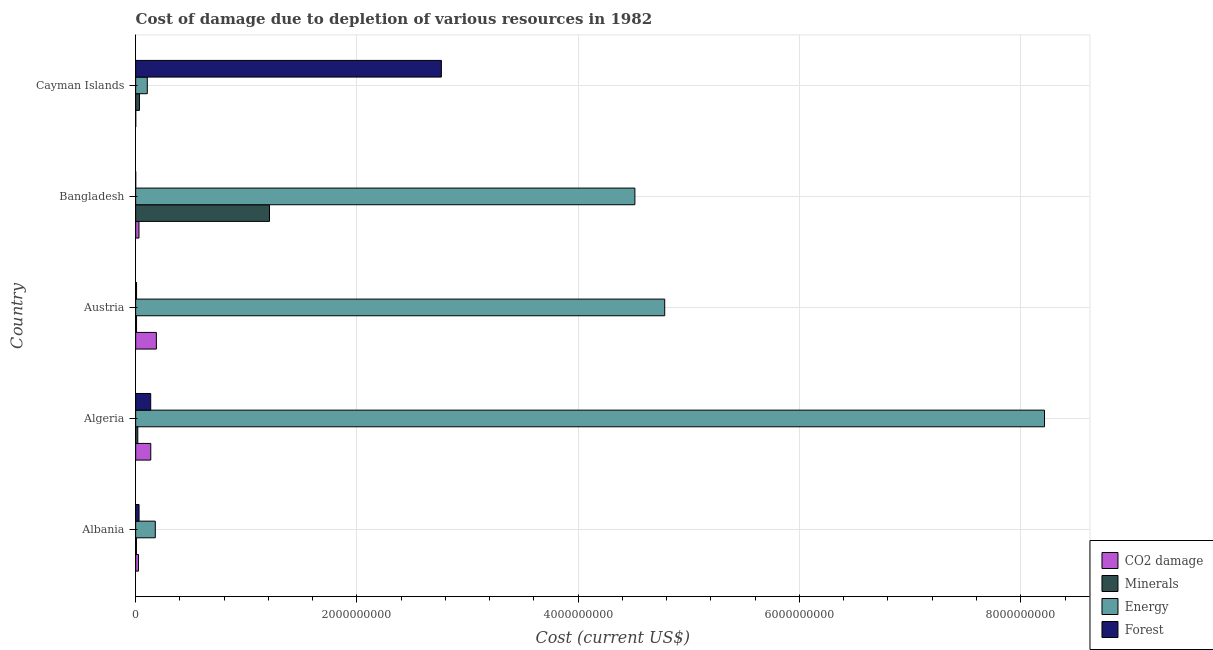How many different coloured bars are there?
Your answer should be very brief. 4. Are the number of bars per tick equal to the number of legend labels?
Your response must be concise. Yes. How many bars are there on the 2nd tick from the top?
Make the answer very short. 4. What is the cost of damage due to depletion of energy in Albania?
Make the answer very short. 1.77e+08. Across all countries, what is the maximum cost of damage due to depletion of forests?
Give a very brief answer. 2.76e+09. Across all countries, what is the minimum cost of damage due to depletion of energy?
Offer a very short reply. 1.05e+08. In which country was the cost of damage due to depletion of energy minimum?
Provide a short and direct response. Cayman Islands. What is the total cost of damage due to depletion of coal in the graph?
Make the answer very short. 3.79e+08. What is the difference between the cost of damage due to depletion of energy in Albania and that in Cayman Islands?
Provide a succinct answer. 7.23e+07. What is the difference between the cost of damage due to depletion of minerals in Bangladesh and the cost of damage due to depletion of energy in Austria?
Offer a terse response. -3.57e+09. What is the average cost of damage due to depletion of energy per country?
Keep it short and to the point. 3.56e+09. What is the difference between the cost of damage due to depletion of energy and cost of damage due to depletion of minerals in Algeria?
Provide a short and direct response. 8.20e+09. In how many countries, is the cost of damage due to depletion of minerals greater than 800000000 US$?
Your answer should be very brief. 1. What is the ratio of the cost of damage due to depletion of coal in Albania to that in Austria?
Your answer should be compact. 0.14. Is the cost of damage due to depletion of forests in Albania less than that in Algeria?
Keep it short and to the point. Yes. What is the difference between the highest and the second highest cost of damage due to depletion of minerals?
Provide a succinct answer. 1.18e+09. What is the difference between the highest and the lowest cost of damage due to depletion of forests?
Your answer should be compact. 2.76e+09. In how many countries, is the cost of damage due to depletion of energy greater than the average cost of damage due to depletion of energy taken over all countries?
Offer a terse response. 3. Is it the case that in every country, the sum of the cost of damage due to depletion of forests and cost of damage due to depletion of energy is greater than the sum of cost of damage due to depletion of coal and cost of damage due to depletion of minerals?
Give a very brief answer. Yes. What does the 4th bar from the top in Austria represents?
Provide a succinct answer. CO2 damage. What does the 1st bar from the bottom in Bangladesh represents?
Keep it short and to the point. CO2 damage. Is it the case that in every country, the sum of the cost of damage due to depletion of coal and cost of damage due to depletion of minerals is greater than the cost of damage due to depletion of energy?
Make the answer very short. No. Are all the bars in the graph horizontal?
Keep it short and to the point. Yes. Does the graph contain any zero values?
Provide a succinct answer. No. Does the graph contain grids?
Provide a succinct answer. Yes. What is the title of the graph?
Offer a very short reply. Cost of damage due to depletion of various resources in 1982 . What is the label or title of the X-axis?
Your answer should be compact. Cost (current US$). What is the Cost (current US$) of CO2 damage in Albania?
Provide a short and direct response. 2.54e+07. What is the Cost (current US$) of Minerals in Albania?
Give a very brief answer. 6.87e+06. What is the Cost (current US$) in Energy in Albania?
Make the answer very short. 1.77e+08. What is the Cost (current US$) of Forest in Albania?
Provide a short and direct response. 3.07e+07. What is the Cost (current US$) of CO2 damage in Algeria?
Ensure brevity in your answer.  1.36e+08. What is the Cost (current US$) of Minerals in Algeria?
Your answer should be compact. 1.92e+07. What is the Cost (current US$) of Energy in Algeria?
Provide a succinct answer. 8.21e+09. What is the Cost (current US$) of Forest in Algeria?
Give a very brief answer. 1.36e+08. What is the Cost (current US$) of CO2 damage in Austria?
Offer a terse response. 1.87e+08. What is the Cost (current US$) of Minerals in Austria?
Provide a succinct answer. 7.86e+06. What is the Cost (current US$) of Energy in Austria?
Make the answer very short. 4.78e+09. What is the Cost (current US$) in Forest in Austria?
Offer a terse response. 8.02e+06. What is the Cost (current US$) in CO2 damage in Bangladesh?
Make the answer very short. 2.99e+07. What is the Cost (current US$) of Minerals in Bangladesh?
Keep it short and to the point. 1.21e+09. What is the Cost (current US$) in Energy in Bangladesh?
Make the answer very short. 4.51e+09. What is the Cost (current US$) in Forest in Bangladesh?
Provide a succinct answer. 2.95e+05. What is the Cost (current US$) in CO2 damage in Cayman Islands?
Your answer should be compact. 5.73e+05. What is the Cost (current US$) in Minerals in Cayman Islands?
Provide a succinct answer. 3.43e+07. What is the Cost (current US$) in Energy in Cayman Islands?
Give a very brief answer. 1.05e+08. What is the Cost (current US$) of Forest in Cayman Islands?
Provide a short and direct response. 2.76e+09. Across all countries, what is the maximum Cost (current US$) of CO2 damage?
Give a very brief answer. 1.87e+08. Across all countries, what is the maximum Cost (current US$) in Minerals?
Give a very brief answer. 1.21e+09. Across all countries, what is the maximum Cost (current US$) of Energy?
Your answer should be very brief. 8.21e+09. Across all countries, what is the maximum Cost (current US$) in Forest?
Offer a terse response. 2.76e+09. Across all countries, what is the minimum Cost (current US$) of CO2 damage?
Your answer should be compact. 5.73e+05. Across all countries, what is the minimum Cost (current US$) of Minerals?
Your answer should be very brief. 6.87e+06. Across all countries, what is the minimum Cost (current US$) in Energy?
Keep it short and to the point. 1.05e+08. Across all countries, what is the minimum Cost (current US$) in Forest?
Offer a terse response. 2.95e+05. What is the total Cost (current US$) in CO2 damage in the graph?
Provide a succinct answer. 3.79e+08. What is the total Cost (current US$) in Minerals in the graph?
Provide a succinct answer. 1.28e+09. What is the total Cost (current US$) in Energy in the graph?
Make the answer very short. 1.78e+1. What is the total Cost (current US$) of Forest in the graph?
Your response must be concise. 2.94e+09. What is the difference between the Cost (current US$) in CO2 damage in Albania and that in Algeria?
Provide a succinct answer. -1.11e+08. What is the difference between the Cost (current US$) in Minerals in Albania and that in Algeria?
Make the answer very short. -1.23e+07. What is the difference between the Cost (current US$) of Energy in Albania and that in Algeria?
Your answer should be very brief. -8.04e+09. What is the difference between the Cost (current US$) in Forest in Albania and that in Algeria?
Give a very brief answer. -1.05e+08. What is the difference between the Cost (current US$) of CO2 damage in Albania and that in Austria?
Keep it short and to the point. -1.62e+08. What is the difference between the Cost (current US$) in Minerals in Albania and that in Austria?
Your answer should be very brief. -9.95e+05. What is the difference between the Cost (current US$) of Energy in Albania and that in Austria?
Offer a very short reply. -4.60e+09. What is the difference between the Cost (current US$) in Forest in Albania and that in Austria?
Provide a succinct answer. 2.26e+07. What is the difference between the Cost (current US$) of CO2 damage in Albania and that in Bangladesh?
Make the answer very short. -4.48e+06. What is the difference between the Cost (current US$) of Minerals in Albania and that in Bangladesh?
Offer a terse response. -1.20e+09. What is the difference between the Cost (current US$) in Energy in Albania and that in Bangladesh?
Provide a succinct answer. -4.33e+09. What is the difference between the Cost (current US$) of Forest in Albania and that in Bangladesh?
Your answer should be compact. 3.04e+07. What is the difference between the Cost (current US$) in CO2 damage in Albania and that in Cayman Islands?
Provide a short and direct response. 2.48e+07. What is the difference between the Cost (current US$) in Minerals in Albania and that in Cayman Islands?
Ensure brevity in your answer.  -2.74e+07. What is the difference between the Cost (current US$) in Energy in Albania and that in Cayman Islands?
Give a very brief answer. 7.23e+07. What is the difference between the Cost (current US$) in Forest in Albania and that in Cayman Islands?
Offer a terse response. -2.73e+09. What is the difference between the Cost (current US$) of CO2 damage in Algeria and that in Austria?
Give a very brief answer. -5.07e+07. What is the difference between the Cost (current US$) in Minerals in Algeria and that in Austria?
Provide a succinct answer. 1.13e+07. What is the difference between the Cost (current US$) of Energy in Algeria and that in Austria?
Offer a terse response. 3.43e+09. What is the difference between the Cost (current US$) of Forest in Algeria and that in Austria?
Provide a short and direct response. 1.28e+08. What is the difference between the Cost (current US$) in CO2 damage in Algeria and that in Bangladesh?
Offer a very short reply. 1.07e+08. What is the difference between the Cost (current US$) in Minerals in Algeria and that in Bangladesh?
Provide a succinct answer. -1.19e+09. What is the difference between the Cost (current US$) in Energy in Algeria and that in Bangladesh?
Make the answer very short. 3.70e+09. What is the difference between the Cost (current US$) of Forest in Algeria and that in Bangladesh?
Provide a short and direct response. 1.36e+08. What is the difference between the Cost (current US$) in CO2 damage in Algeria and that in Cayman Islands?
Your response must be concise. 1.36e+08. What is the difference between the Cost (current US$) in Minerals in Algeria and that in Cayman Islands?
Offer a terse response. -1.51e+07. What is the difference between the Cost (current US$) in Energy in Algeria and that in Cayman Islands?
Provide a short and direct response. 8.11e+09. What is the difference between the Cost (current US$) in Forest in Algeria and that in Cayman Islands?
Your answer should be very brief. -2.63e+09. What is the difference between the Cost (current US$) of CO2 damage in Austria and that in Bangladesh?
Offer a very short reply. 1.57e+08. What is the difference between the Cost (current US$) of Minerals in Austria and that in Bangladesh?
Provide a succinct answer. -1.20e+09. What is the difference between the Cost (current US$) in Energy in Austria and that in Bangladesh?
Give a very brief answer. 2.70e+08. What is the difference between the Cost (current US$) in Forest in Austria and that in Bangladesh?
Ensure brevity in your answer.  7.72e+06. What is the difference between the Cost (current US$) in CO2 damage in Austria and that in Cayman Islands?
Offer a very short reply. 1.87e+08. What is the difference between the Cost (current US$) of Minerals in Austria and that in Cayman Islands?
Give a very brief answer. -2.64e+07. What is the difference between the Cost (current US$) in Energy in Austria and that in Cayman Islands?
Keep it short and to the point. 4.68e+09. What is the difference between the Cost (current US$) of Forest in Austria and that in Cayman Islands?
Your response must be concise. -2.76e+09. What is the difference between the Cost (current US$) in CO2 damage in Bangladesh and that in Cayman Islands?
Give a very brief answer. 2.93e+07. What is the difference between the Cost (current US$) of Minerals in Bangladesh and that in Cayman Islands?
Your answer should be compact. 1.18e+09. What is the difference between the Cost (current US$) of Energy in Bangladesh and that in Cayman Islands?
Your answer should be compact. 4.41e+09. What is the difference between the Cost (current US$) of Forest in Bangladesh and that in Cayman Islands?
Provide a succinct answer. -2.76e+09. What is the difference between the Cost (current US$) of CO2 damage in Albania and the Cost (current US$) of Minerals in Algeria?
Offer a very short reply. 6.20e+06. What is the difference between the Cost (current US$) in CO2 damage in Albania and the Cost (current US$) in Energy in Algeria?
Provide a succinct answer. -8.19e+09. What is the difference between the Cost (current US$) in CO2 damage in Albania and the Cost (current US$) in Forest in Algeria?
Make the answer very short. -1.11e+08. What is the difference between the Cost (current US$) in Minerals in Albania and the Cost (current US$) in Energy in Algeria?
Provide a short and direct response. -8.21e+09. What is the difference between the Cost (current US$) in Minerals in Albania and the Cost (current US$) in Forest in Algeria?
Offer a terse response. -1.29e+08. What is the difference between the Cost (current US$) of Energy in Albania and the Cost (current US$) of Forest in Algeria?
Offer a terse response. 4.15e+07. What is the difference between the Cost (current US$) of CO2 damage in Albania and the Cost (current US$) of Minerals in Austria?
Ensure brevity in your answer.  1.75e+07. What is the difference between the Cost (current US$) of CO2 damage in Albania and the Cost (current US$) of Energy in Austria?
Offer a very short reply. -4.76e+09. What is the difference between the Cost (current US$) in CO2 damage in Albania and the Cost (current US$) in Forest in Austria?
Your answer should be compact. 1.74e+07. What is the difference between the Cost (current US$) in Minerals in Albania and the Cost (current US$) in Energy in Austria?
Make the answer very short. -4.78e+09. What is the difference between the Cost (current US$) of Minerals in Albania and the Cost (current US$) of Forest in Austria?
Offer a terse response. -1.15e+06. What is the difference between the Cost (current US$) in Energy in Albania and the Cost (current US$) in Forest in Austria?
Your response must be concise. 1.69e+08. What is the difference between the Cost (current US$) of CO2 damage in Albania and the Cost (current US$) of Minerals in Bangladesh?
Your answer should be compact. -1.18e+09. What is the difference between the Cost (current US$) in CO2 damage in Albania and the Cost (current US$) in Energy in Bangladesh?
Keep it short and to the point. -4.49e+09. What is the difference between the Cost (current US$) in CO2 damage in Albania and the Cost (current US$) in Forest in Bangladesh?
Make the answer very short. 2.51e+07. What is the difference between the Cost (current US$) in Minerals in Albania and the Cost (current US$) in Energy in Bangladesh?
Your response must be concise. -4.51e+09. What is the difference between the Cost (current US$) in Minerals in Albania and the Cost (current US$) in Forest in Bangladesh?
Offer a very short reply. 6.57e+06. What is the difference between the Cost (current US$) of Energy in Albania and the Cost (current US$) of Forest in Bangladesh?
Your response must be concise. 1.77e+08. What is the difference between the Cost (current US$) of CO2 damage in Albania and the Cost (current US$) of Minerals in Cayman Islands?
Offer a terse response. -8.88e+06. What is the difference between the Cost (current US$) of CO2 damage in Albania and the Cost (current US$) of Energy in Cayman Islands?
Offer a terse response. -7.97e+07. What is the difference between the Cost (current US$) of CO2 damage in Albania and the Cost (current US$) of Forest in Cayman Islands?
Your answer should be very brief. -2.74e+09. What is the difference between the Cost (current US$) of Minerals in Albania and the Cost (current US$) of Energy in Cayman Islands?
Offer a very short reply. -9.82e+07. What is the difference between the Cost (current US$) of Minerals in Albania and the Cost (current US$) of Forest in Cayman Islands?
Keep it short and to the point. -2.76e+09. What is the difference between the Cost (current US$) of Energy in Albania and the Cost (current US$) of Forest in Cayman Islands?
Ensure brevity in your answer.  -2.59e+09. What is the difference between the Cost (current US$) of CO2 damage in Algeria and the Cost (current US$) of Minerals in Austria?
Your response must be concise. 1.29e+08. What is the difference between the Cost (current US$) of CO2 damage in Algeria and the Cost (current US$) of Energy in Austria?
Provide a short and direct response. -4.65e+09. What is the difference between the Cost (current US$) in CO2 damage in Algeria and the Cost (current US$) in Forest in Austria?
Ensure brevity in your answer.  1.28e+08. What is the difference between the Cost (current US$) in Minerals in Algeria and the Cost (current US$) in Energy in Austria?
Provide a short and direct response. -4.76e+09. What is the difference between the Cost (current US$) in Minerals in Algeria and the Cost (current US$) in Forest in Austria?
Give a very brief answer. 1.12e+07. What is the difference between the Cost (current US$) in Energy in Algeria and the Cost (current US$) in Forest in Austria?
Keep it short and to the point. 8.21e+09. What is the difference between the Cost (current US$) in CO2 damage in Algeria and the Cost (current US$) in Minerals in Bangladesh?
Give a very brief answer. -1.07e+09. What is the difference between the Cost (current US$) of CO2 damage in Algeria and the Cost (current US$) of Energy in Bangladesh?
Provide a short and direct response. -4.38e+09. What is the difference between the Cost (current US$) in CO2 damage in Algeria and the Cost (current US$) in Forest in Bangladesh?
Give a very brief answer. 1.36e+08. What is the difference between the Cost (current US$) in Minerals in Algeria and the Cost (current US$) in Energy in Bangladesh?
Offer a terse response. -4.49e+09. What is the difference between the Cost (current US$) of Minerals in Algeria and the Cost (current US$) of Forest in Bangladesh?
Make the answer very short. 1.89e+07. What is the difference between the Cost (current US$) of Energy in Algeria and the Cost (current US$) of Forest in Bangladesh?
Offer a very short reply. 8.21e+09. What is the difference between the Cost (current US$) of CO2 damage in Algeria and the Cost (current US$) of Minerals in Cayman Islands?
Offer a very short reply. 1.02e+08. What is the difference between the Cost (current US$) of CO2 damage in Algeria and the Cost (current US$) of Energy in Cayman Islands?
Provide a succinct answer. 3.13e+07. What is the difference between the Cost (current US$) of CO2 damage in Algeria and the Cost (current US$) of Forest in Cayman Islands?
Offer a very short reply. -2.63e+09. What is the difference between the Cost (current US$) of Minerals in Algeria and the Cost (current US$) of Energy in Cayman Islands?
Offer a terse response. -8.59e+07. What is the difference between the Cost (current US$) in Minerals in Algeria and the Cost (current US$) in Forest in Cayman Islands?
Your answer should be very brief. -2.74e+09. What is the difference between the Cost (current US$) in Energy in Algeria and the Cost (current US$) in Forest in Cayman Islands?
Your answer should be very brief. 5.45e+09. What is the difference between the Cost (current US$) of CO2 damage in Austria and the Cost (current US$) of Minerals in Bangladesh?
Offer a very short reply. -1.02e+09. What is the difference between the Cost (current US$) of CO2 damage in Austria and the Cost (current US$) of Energy in Bangladesh?
Offer a terse response. -4.33e+09. What is the difference between the Cost (current US$) in CO2 damage in Austria and the Cost (current US$) in Forest in Bangladesh?
Provide a short and direct response. 1.87e+08. What is the difference between the Cost (current US$) of Minerals in Austria and the Cost (current US$) of Energy in Bangladesh?
Give a very brief answer. -4.50e+09. What is the difference between the Cost (current US$) in Minerals in Austria and the Cost (current US$) in Forest in Bangladesh?
Provide a succinct answer. 7.57e+06. What is the difference between the Cost (current US$) in Energy in Austria and the Cost (current US$) in Forest in Bangladesh?
Keep it short and to the point. 4.78e+09. What is the difference between the Cost (current US$) of CO2 damage in Austria and the Cost (current US$) of Minerals in Cayman Islands?
Offer a terse response. 1.53e+08. What is the difference between the Cost (current US$) of CO2 damage in Austria and the Cost (current US$) of Energy in Cayman Islands?
Offer a very short reply. 8.20e+07. What is the difference between the Cost (current US$) in CO2 damage in Austria and the Cost (current US$) in Forest in Cayman Islands?
Offer a very short reply. -2.58e+09. What is the difference between the Cost (current US$) of Minerals in Austria and the Cost (current US$) of Energy in Cayman Islands?
Provide a succinct answer. -9.72e+07. What is the difference between the Cost (current US$) of Minerals in Austria and the Cost (current US$) of Forest in Cayman Islands?
Offer a very short reply. -2.76e+09. What is the difference between the Cost (current US$) in Energy in Austria and the Cost (current US$) in Forest in Cayman Islands?
Give a very brief answer. 2.02e+09. What is the difference between the Cost (current US$) of CO2 damage in Bangladesh and the Cost (current US$) of Minerals in Cayman Islands?
Give a very brief answer. -4.40e+06. What is the difference between the Cost (current US$) of CO2 damage in Bangladesh and the Cost (current US$) of Energy in Cayman Islands?
Your answer should be very brief. -7.52e+07. What is the difference between the Cost (current US$) in CO2 damage in Bangladesh and the Cost (current US$) in Forest in Cayman Islands?
Offer a terse response. -2.73e+09. What is the difference between the Cost (current US$) of Minerals in Bangladesh and the Cost (current US$) of Energy in Cayman Islands?
Offer a very short reply. 1.10e+09. What is the difference between the Cost (current US$) in Minerals in Bangladesh and the Cost (current US$) in Forest in Cayman Islands?
Make the answer very short. -1.55e+09. What is the difference between the Cost (current US$) in Energy in Bangladesh and the Cost (current US$) in Forest in Cayman Islands?
Give a very brief answer. 1.75e+09. What is the average Cost (current US$) in CO2 damage per country?
Offer a very short reply. 7.59e+07. What is the average Cost (current US$) in Minerals per country?
Your response must be concise. 2.56e+08. What is the average Cost (current US$) of Energy per country?
Your answer should be very brief. 3.56e+09. What is the average Cost (current US$) of Forest per country?
Provide a succinct answer. 5.88e+08. What is the difference between the Cost (current US$) of CO2 damage and Cost (current US$) of Minerals in Albania?
Your answer should be very brief. 1.85e+07. What is the difference between the Cost (current US$) of CO2 damage and Cost (current US$) of Energy in Albania?
Keep it short and to the point. -1.52e+08. What is the difference between the Cost (current US$) in CO2 damage and Cost (current US$) in Forest in Albania?
Your answer should be compact. -5.27e+06. What is the difference between the Cost (current US$) of Minerals and Cost (current US$) of Energy in Albania?
Offer a very short reply. -1.71e+08. What is the difference between the Cost (current US$) in Minerals and Cost (current US$) in Forest in Albania?
Your answer should be very brief. -2.38e+07. What is the difference between the Cost (current US$) in Energy and Cost (current US$) in Forest in Albania?
Your response must be concise. 1.47e+08. What is the difference between the Cost (current US$) in CO2 damage and Cost (current US$) in Minerals in Algeria?
Make the answer very short. 1.17e+08. What is the difference between the Cost (current US$) in CO2 damage and Cost (current US$) in Energy in Algeria?
Your answer should be very brief. -8.08e+09. What is the difference between the Cost (current US$) in CO2 damage and Cost (current US$) in Forest in Algeria?
Ensure brevity in your answer.  4.85e+05. What is the difference between the Cost (current US$) of Minerals and Cost (current US$) of Energy in Algeria?
Make the answer very short. -8.20e+09. What is the difference between the Cost (current US$) in Minerals and Cost (current US$) in Forest in Algeria?
Make the answer very short. -1.17e+08. What is the difference between the Cost (current US$) in Energy and Cost (current US$) in Forest in Algeria?
Ensure brevity in your answer.  8.08e+09. What is the difference between the Cost (current US$) of CO2 damage and Cost (current US$) of Minerals in Austria?
Offer a very short reply. 1.79e+08. What is the difference between the Cost (current US$) of CO2 damage and Cost (current US$) of Energy in Austria?
Provide a succinct answer. -4.59e+09. What is the difference between the Cost (current US$) of CO2 damage and Cost (current US$) of Forest in Austria?
Your response must be concise. 1.79e+08. What is the difference between the Cost (current US$) in Minerals and Cost (current US$) in Energy in Austria?
Make the answer very short. -4.77e+09. What is the difference between the Cost (current US$) of Minerals and Cost (current US$) of Forest in Austria?
Give a very brief answer. -1.59e+05. What is the difference between the Cost (current US$) of Energy and Cost (current US$) of Forest in Austria?
Your answer should be very brief. 4.77e+09. What is the difference between the Cost (current US$) of CO2 damage and Cost (current US$) of Minerals in Bangladesh?
Your response must be concise. -1.18e+09. What is the difference between the Cost (current US$) of CO2 damage and Cost (current US$) of Energy in Bangladesh?
Ensure brevity in your answer.  -4.48e+09. What is the difference between the Cost (current US$) of CO2 damage and Cost (current US$) of Forest in Bangladesh?
Offer a terse response. 2.96e+07. What is the difference between the Cost (current US$) of Minerals and Cost (current US$) of Energy in Bangladesh?
Keep it short and to the point. -3.30e+09. What is the difference between the Cost (current US$) of Minerals and Cost (current US$) of Forest in Bangladesh?
Offer a terse response. 1.21e+09. What is the difference between the Cost (current US$) of Energy and Cost (current US$) of Forest in Bangladesh?
Offer a terse response. 4.51e+09. What is the difference between the Cost (current US$) of CO2 damage and Cost (current US$) of Minerals in Cayman Islands?
Your response must be concise. -3.37e+07. What is the difference between the Cost (current US$) in CO2 damage and Cost (current US$) in Energy in Cayman Islands?
Your answer should be compact. -1.05e+08. What is the difference between the Cost (current US$) of CO2 damage and Cost (current US$) of Forest in Cayman Islands?
Ensure brevity in your answer.  -2.76e+09. What is the difference between the Cost (current US$) of Minerals and Cost (current US$) of Energy in Cayman Islands?
Your response must be concise. -7.08e+07. What is the difference between the Cost (current US$) of Minerals and Cost (current US$) of Forest in Cayman Islands?
Give a very brief answer. -2.73e+09. What is the difference between the Cost (current US$) in Energy and Cost (current US$) in Forest in Cayman Islands?
Keep it short and to the point. -2.66e+09. What is the ratio of the Cost (current US$) of CO2 damage in Albania to that in Algeria?
Your response must be concise. 0.19. What is the ratio of the Cost (current US$) in Minerals in Albania to that in Algeria?
Make the answer very short. 0.36. What is the ratio of the Cost (current US$) of Energy in Albania to that in Algeria?
Your response must be concise. 0.02. What is the ratio of the Cost (current US$) of Forest in Albania to that in Algeria?
Your answer should be very brief. 0.23. What is the ratio of the Cost (current US$) of CO2 damage in Albania to that in Austria?
Provide a succinct answer. 0.14. What is the ratio of the Cost (current US$) of Minerals in Albania to that in Austria?
Offer a terse response. 0.87. What is the ratio of the Cost (current US$) in Energy in Albania to that in Austria?
Provide a short and direct response. 0.04. What is the ratio of the Cost (current US$) in Forest in Albania to that in Austria?
Make the answer very short. 3.82. What is the ratio of the Cost (current US$) in CO2 damage in Albania to that in Bangladesh?
Offer a terse response. 0.85. What is the ratio of the Cost (current US$) in Minerals in Albania to that in Bangladesh?
Your response must be concise. 0.01. What is the ratio of the Cost (current US$) in Energy in Albania to that in Bangladesh?
Your answer should be compact. 0.04. What is the ratio of the Cost (current US$) of Forest in Albania to that in Bangladesh?
Provide a short and direct response. 103.98. What is the ratio of the Cost (current US$) of CO2 damage in Albania to that in Cayman Islands?
Your answer should be very brief. 44.29. What is the ratio of the Cost (current US$) in Minerals in Albania to that in Cayman Islands?
Your answer should be very brief. 0.2. What is the ratio of the Cost (current US$) in Energy in Albania to that in Cayman Islands?
Provide a succinct answer. 1.69. What is the ratio of the Cost (current US$) of Forest in Albania to that in Cayman Islands?
Your answer should be very brief. 0.01. What is the ratio of the Cost (current US$) in CO2 damage in Algeria to that in Austria?
Give a very brief answer. 0.73. What is the ratio of the Cost (current US$) in Minerals in Algeria to that in Austria?
Keep it short and to the point. 2.44. What is the ratio of the Cost (current US$) of Energy in Algeria to that in Austria?
Ensure brevity in your answer.  1.72. What is the ratio of the Cost (current US$) in Forest in Algeria to that in Austria?
Keep it short and to the point. 16.95. What is the ratio of the Cost (current US$) of CO2 damage in Algeria to that in Bangladesh?
Your answer should be compact. 4.57. What is the ratio of the Cost (current US$) of Minerals in Algeria to that in Bangladesh?
Provide a short and direct response. 0.02. What is the ratio of the Cost (current US$) of Energy in Algeria to that in Bangladesh?
Make the answer very short. 1.82. What is the ratio of the Cost (current US$) of Forest in Algeria to that in Bangladesh?
Your answer should be compact. 460.96. What is the ratio of the Cost (current US$) in CO2 damage in Algeria to that in Cayman Islands?
Keep it short and to the point. 237.98. What is the ratio of the Cost (current US$) of Minerals in Algeria to that in Cayman Islands?
Ensure brevity in your answer.  0.56. What is the ratio of the Cost (current US$) in Energy in Algeria to that in Cayman Islands?
Offer a very short reply. 78.16. What is the ratio of the Cost (current US$) of Forest in Algeria to that in Cayman Islands?
Provide a succinct answer. 0.05. What is the ratio of the Cost (current US$) of CO2 damage in Austria to that in Bangladesh?
Provide a short and direct response. 6.26. What is the ratio of the Cost (current US$) in Minerals in Austria to that in Bangladesh?
Offer a very short reply. 0.01. What is the ratio of the Cost (current US$) of Energy in Austria to that in Bangladesh?
Offer a very short reply. 1.06. What is the ratio of the Cost (current US$) of Forest in Austria to that in Bangladesh?
Keep it short and to the point. 27.2. What is the ratio of the Cost (current US$) of CO2 damage in Austria to that in Cayman Islands?
Provide a short and direct response. 326.44. What is the ratio of the Cost (current US$) in Minerals in Austria to that in Cayman Islands?
Keep it short and to the point. 0.23. What is the ratio of the Cost (current US$) of Energy in Austria to that in Cayman Islands?
Ensure brevity in your answer.  45.5. What is the ratio of the Cost (current US$) in Forest in Austria to that in Cayman Islands?
Give a very brief answer. 0. What is the ratio of the Cost (current US$) in CO2 damage in Bangladesh to that in Cayman Islands?
Your answer should be compact. 52.11. What is the ratio of the Cost (current US$) of Minerals in Bangladesh to that in Cayman Islands?
Offer a very short reply. 35.29. What is the ratio of the Cost (current US$) in Energy in Bangladesh to that in Cayman Islands?
Ensure brevity in your answer.  42.93. What is the ratio of the Cost (current US$) of Forest in Bangladesh to that in Cayman Islands?
Make the answer very short. 0. What is the difference between the highest and the second highest Cost (current US$) of CO2 damage?
Offer a very short reply. 5.07e+07. What is the difference between the highest and the second highest Cost (current US$) of Minerals?
Ensure brevity in your answer.  1.18e+09. What is the difference between the highest and the second highest Cost (current US$) in Energy?
Ensure brevity in your answer.  3.43e+09. What is the difference between the highest and the second highest Cost (current US$) in Forest?
Your answer should be compact. 2.63e+09. What is the difference between the highest and the lowest Cost (current US$) of CO2 damage?
Give a very brief answer. 1.87e+08. What is the difference between the highest and the lowest Cost (current US$) in Minerals?
Your response must be concise. 1.20e+09. What is the difference between the highest and the lowest Cost (current US$) in Energy?
Make the answer very short. 8.11e+09. What is the difference between the highest and the lowest Cost (current US$) of Forest?
Ensure brevity in your answer.  2.76e+09. 